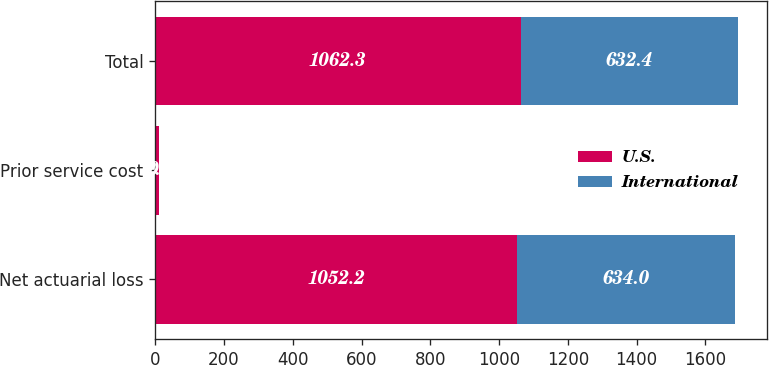Convert chart. <chart><loc_0><loc_0><loc_500><loc_500><stacked_bar_chart><ecel><fcel>Net actuarial loss<fcel>Prior service cost<fcel>Total<nl><fcel>U.S.<fcel>1052.2<fcel>10.1<fcel>1062.3<nl><fcel>International<fcel>634<fcel>2<fcel>632.4<nl></chart> 